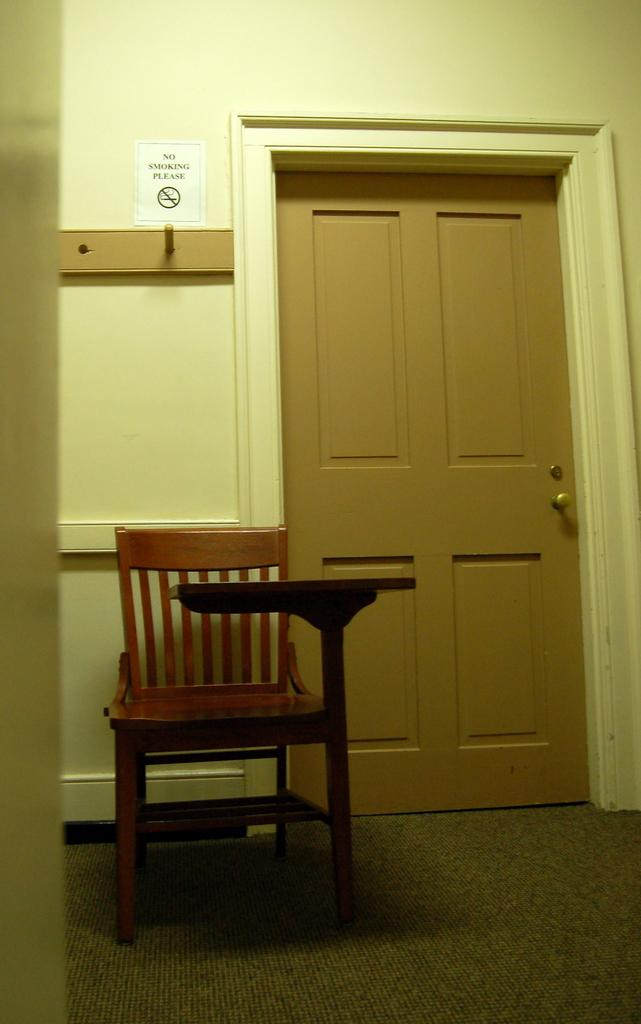What type of chair is visible in the image? There is a chair with armrests in the image. What can be seen in the background of the image? There is a door in the background of the image. What is on the wall in the image? There is a wall with paper in the image. What is written or depicted on the paper? There is text and a sign on the paper. Can you tell me how many baseballs are on the chair in the image? There are no baseballs present in the image; it features a chair with armrests, a door in the background, a wall with paper, and text and a sign on the paper. What is the chair's opinion on the sign in the image? The chair does not have an opinion, as it is an inanimate object. 